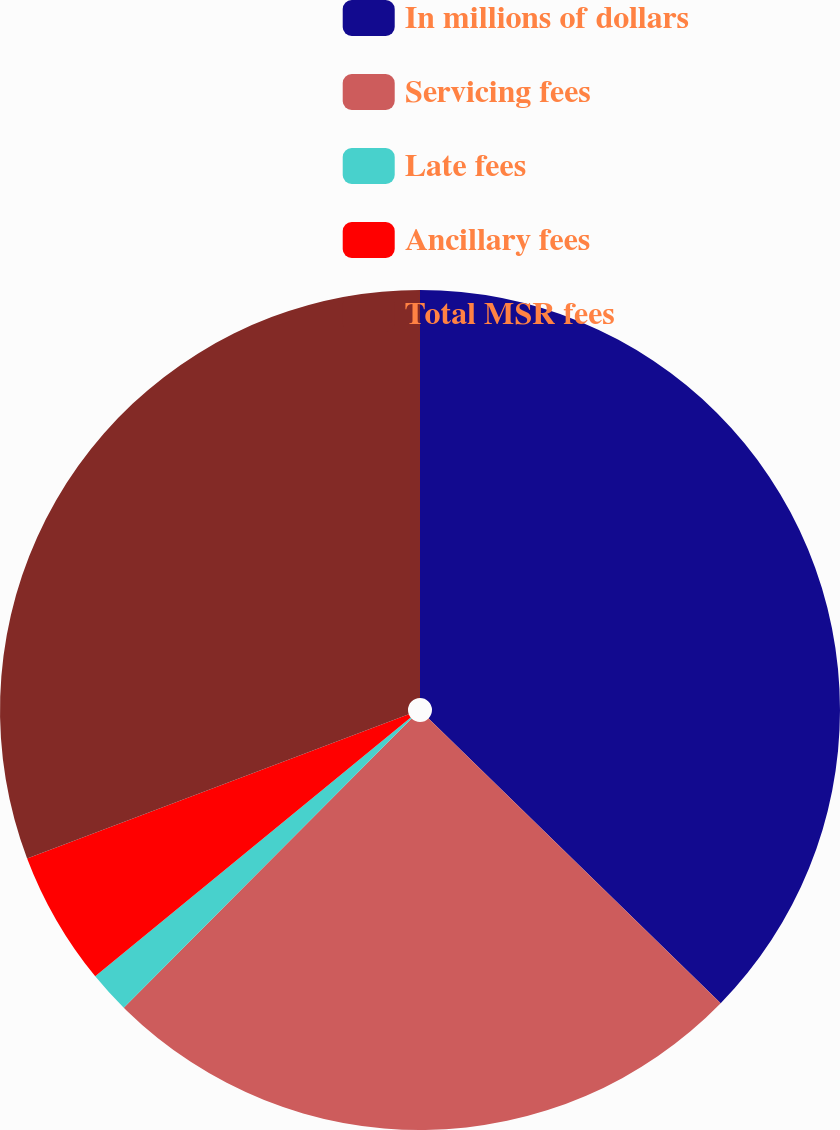<chart> <loc_0><loc_0><loc_500><loc_500><pie_chart><fcel>In millions of dollars<fcel>Servicing fees<fcel>Late fees<fcel>Ancillary fees<fcel>Total MSR fees<nl><fcel>37.3%<fcel>25.16%<fcel>1.61%<fcel>5.18%<fcel>30.75%<nl></chart> 